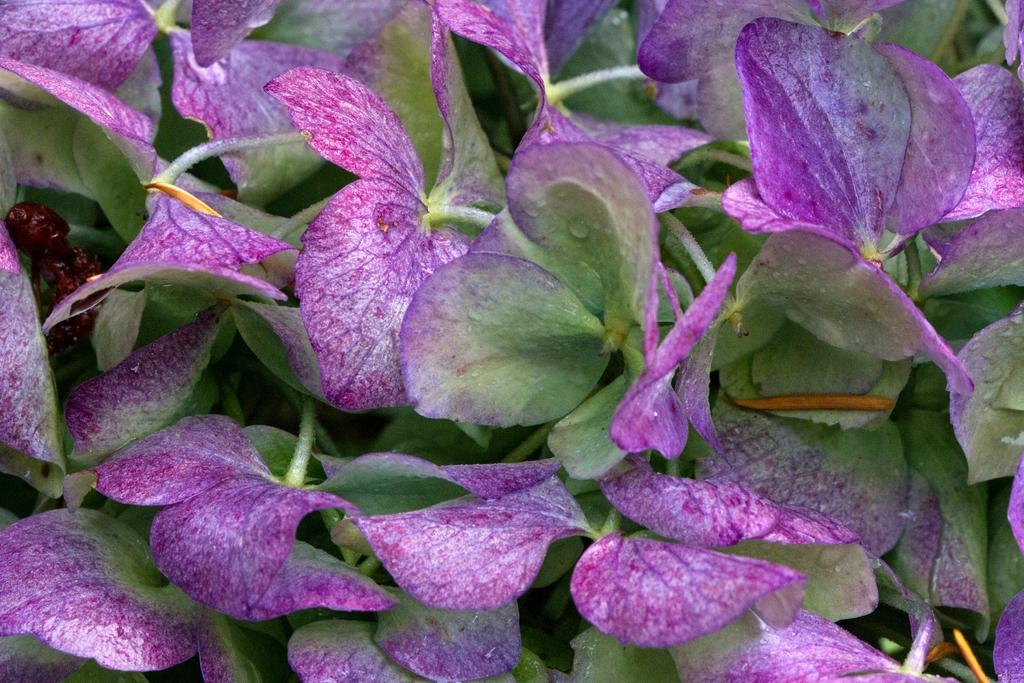What is the main subject of the image? The main subject of the image is a plant with many flowers. Can you describe the plant in the image? The plant has many flowers on it. Are there any other living organisms present in the image? Yes, there is an insect on the plant in the image. What type of toys can be seen in the image? There are no toys present in the image; it features a plant with many flowers and an insect. Can you tell me the eye color of the owner of the plant in the image? There is no owner visible in the image, and therefore no eye color can be determined. 